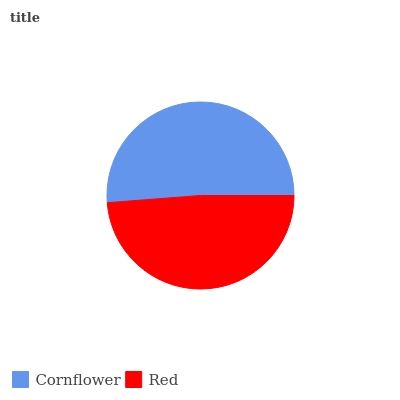Is Red the minimum?
Answer yes or no. Yes. Is Cornflower the maximum?
Answer yes or no. Yes. Is Red the maximum?
Answer yes or no. No. Is Cornflower greater than Red?
Answer yes or no. Yes. Is Red less than Cornflower?
Answer yes or no. Yes. Is Red greater than Cornflower?
Answer yes or no. No. Is Cornflower less than Red?
Answer yes or no. No. Is Cornflower the high median?
Answer yes or no. Yes. Is Red the low median?
Answer yes or no. Yes. Is Red the high median?
Answer yes or no. No. Is Cornflower the low median?
Answer yes or no. No. 